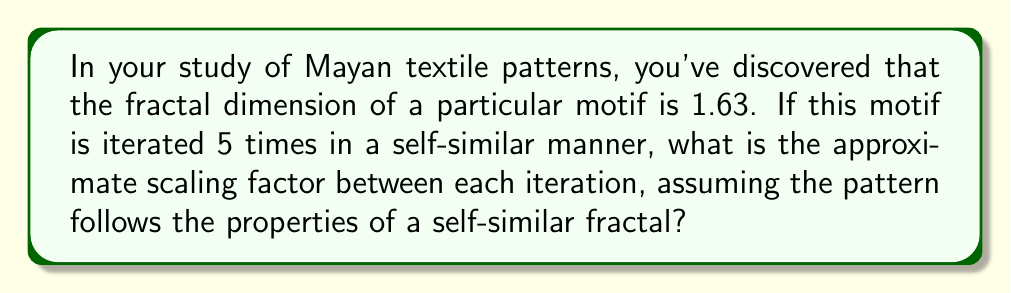Teach me how to tackle this problem. Let's approach this step-by-step using concepts from fractal geometry and chaos theory:

1) For a self-similar fractal, the fractal dimension $D$ is related to the number of self-similar pieces $N$ and the scaling factor $r$ by the equation:

   $$D = \frac{\log N}{\log(\frac{1}{r})}$$

2) We know the fractal dimension $D = 1.63$ and we need to find $r$. We don't know $N$, but we can determine it from the number of iterations.

3) With 5 iterations, the number of self-similar pieces is typically $N = 2^5 = 32$. This assumes binary subdivision, which is common in many fractals.

4) Substituting these values into our equation:

   $$1.63 = \frac{\log 32}{\log(\frac{1}{r})}$$

5) We can solve this for $r$:

   $$\log(\frac{1}{r}) = \frac{\log 32}{1.63}$$

   $$\frac{1}{r} = 32^{\frac{1}{1.63}}$$

   $$r = 32^{-\frac{1}{1.63}}$$

6) Using a calculator or computer, we can evaluate this:

   $$r \approx 0.4645$$

7) This means that each iteration of the fractal is scaled down by a factor of approximately 0.4645 compared to the previous iteration.

This scaling factor provides insight into how the cultural motif repeats at different scales, potentially reflecting hierarchical structures or natural patterns that influenced Mayan design.
Answer: $r \approx 0.4645$ 